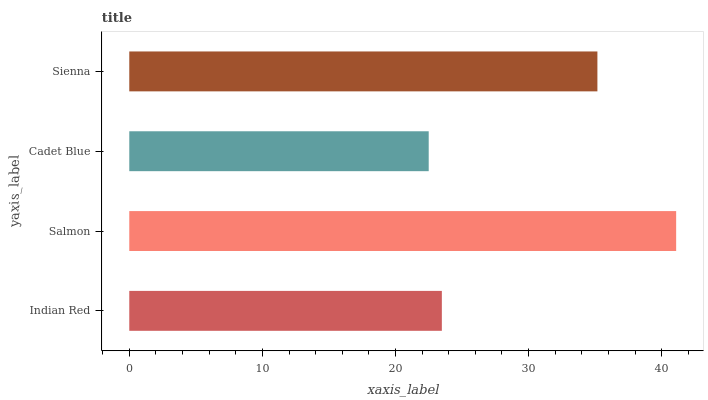Is Cadet Blue the minimum?
Answer yes or no. Yes. Is Salmon the maximum?
Answer yes or no. Yes. Is Salmon the minimum?
Answer yes or no. No. Is Cadet Blue the maximum?
Answer yes or no. No. Is Salmon greater than Cadet Blue?
Answer yes or no. Yes. Is Cadet Blue less than Salmon?
Answer yes or no. Yes. Is Cadet Blue greater than Salmon?
Answer yes or no. No. Is Salmon less than Cadet Blue?
Answer yes or no. No. Is Sienna the high median?
Answer yes or no. Yes. Is Indian Red the low median?
Answer yes or no. Yes. Is Salmon the high median?
Answer yes or no. No. Is Salmon the low median?
Answer yes or no. No. 